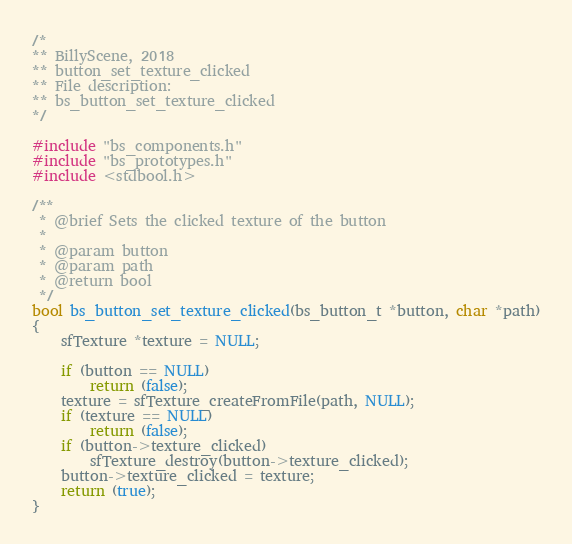<code> <loc_0><loc_0><loc_500><loc_500><_C_>/*
** BillyScene, 2018
** button_set_texture_clicked
** File description:
** bs_button_set_texture_clicked
*/

#include "bs_components.h"
#include "bs_prototypes.h"
#include <stdbool.h>

/**
 * @brief Sets the clicked texture of the button
 * 
 * @param button
 * @param path
 * @return bool
 */
bool bs_button_set_texture_clicked(bs_button_t *button, char *path)
{
    sfTexture *texture = NULL;

    if (button == NULL)
        return (false);
    texture = sfTexture_createFromFile(path, NULL);
    if (texture == NULL)
        return (false);
    if (button->texture_clicked)
        sfTexture_destroy(button->texture_clicked);
    button->texture_clicked = texture;
    return (true);
}
</code> 